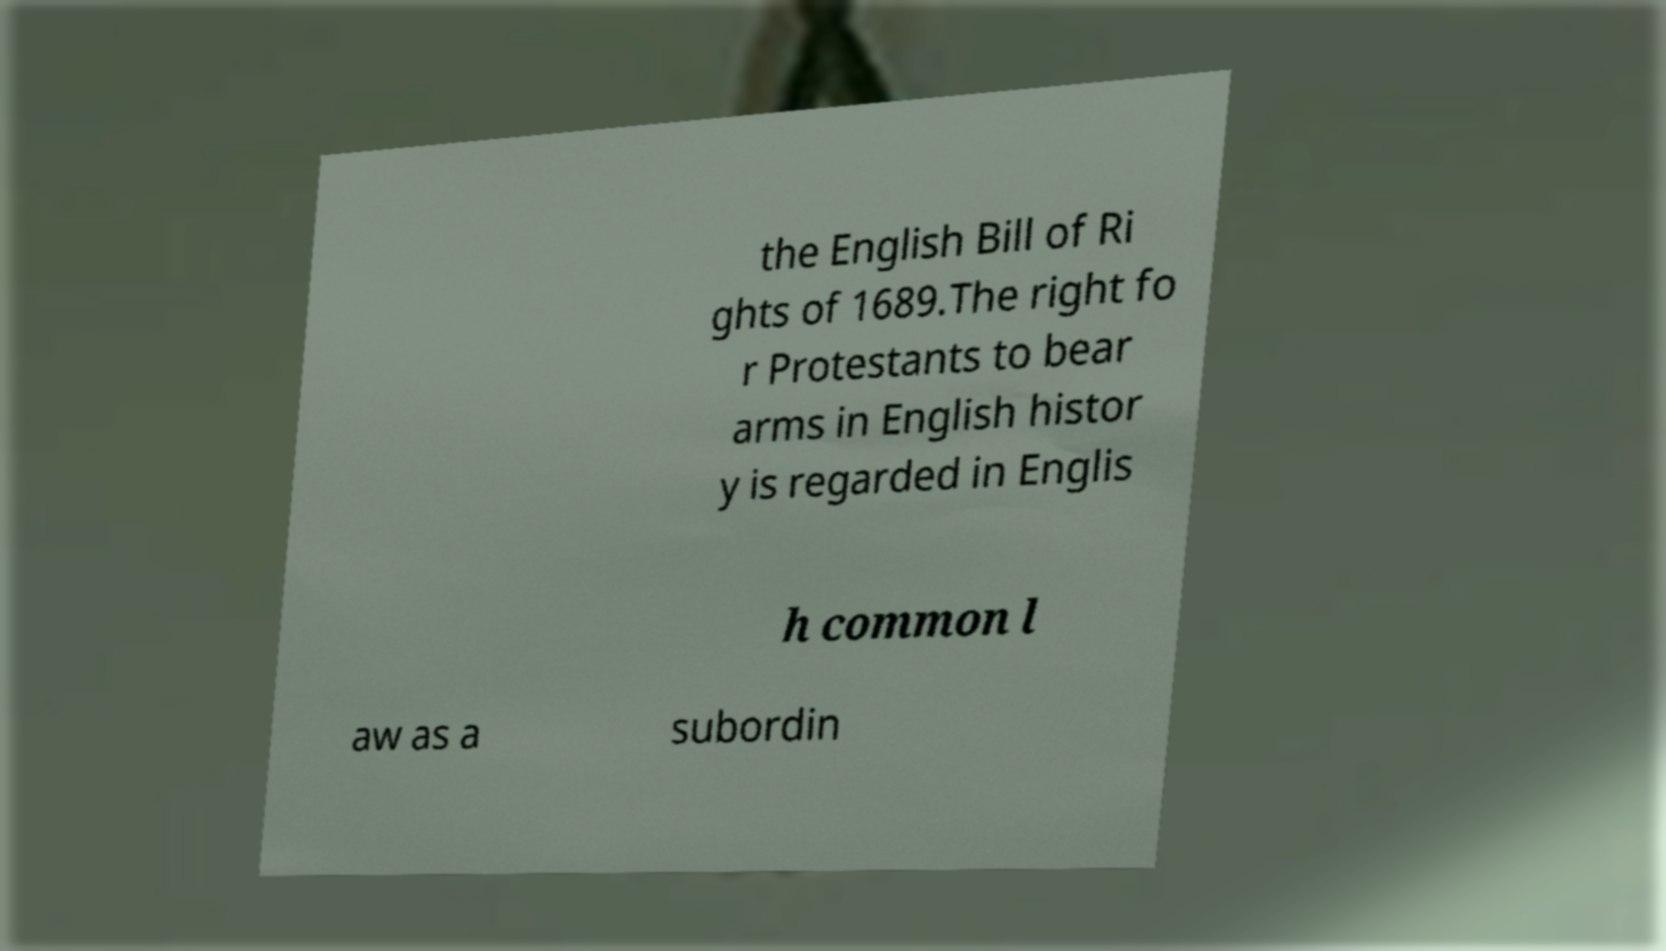I need the written content from this picture converted into text. Can you do that? the English Bill of Ri ghts of 1689.The right fo r Protestants to bear arms in English histor y is regarded in Englis h common l aw as a subordin 